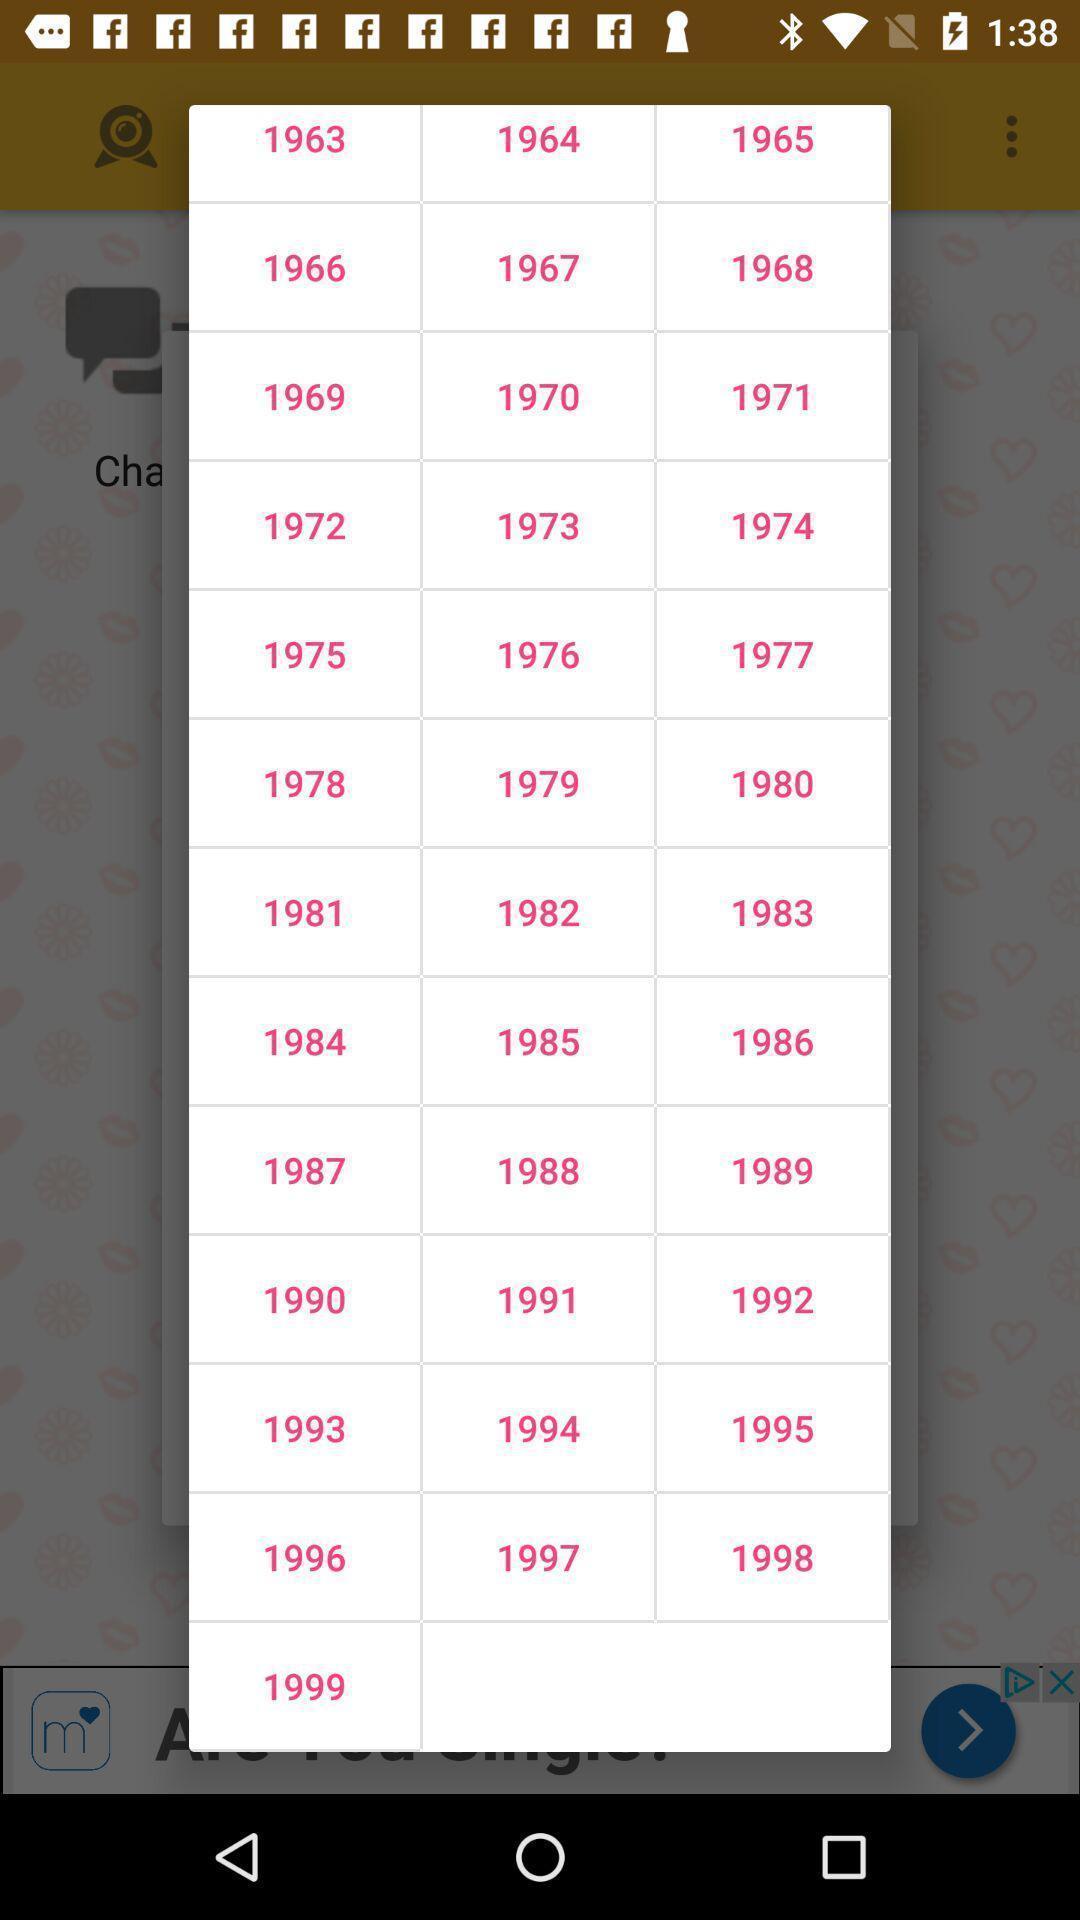Tell me what you see in this picture. Popup showing of different years. 